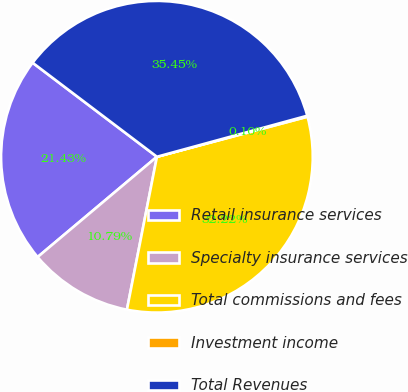Convert chart. <chart><loc_0><loc_0><loc_500><loc_500><pie_chart><fcel>Retail insurance services<fcel>Specialty insurance services<fcel>Total commissions and fees<fcel>Investment income<fcel>Total Revenues<nl><fcel>21.43%<fcel>10.79%<fcel>32.22%<fcel>0.1%<fcel>35.45%<nl></chart> 